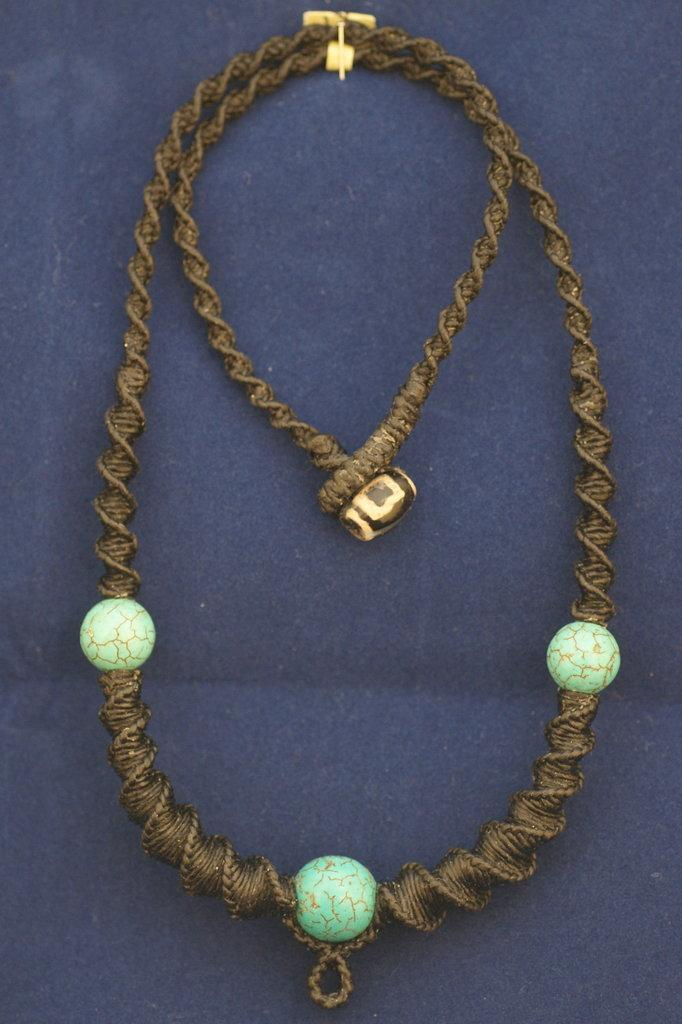What is the main object in the image? There is a chain in the image. What is the chain placed on? The chain is on a blue color cloth. How many stitches are visible on the chain in the image? There are no stitches visible on the chain in the image, as it is a physical object and not a piece of fabric. 